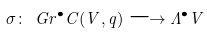Convert formula to latex. <formula><loc_0><loc_0><loc_500><loc_500>\sigma \colon \ G r ^ { \bullet } C ( V , q ) \longrightarrow \Lambda ^ { \bullet } V</formula> 